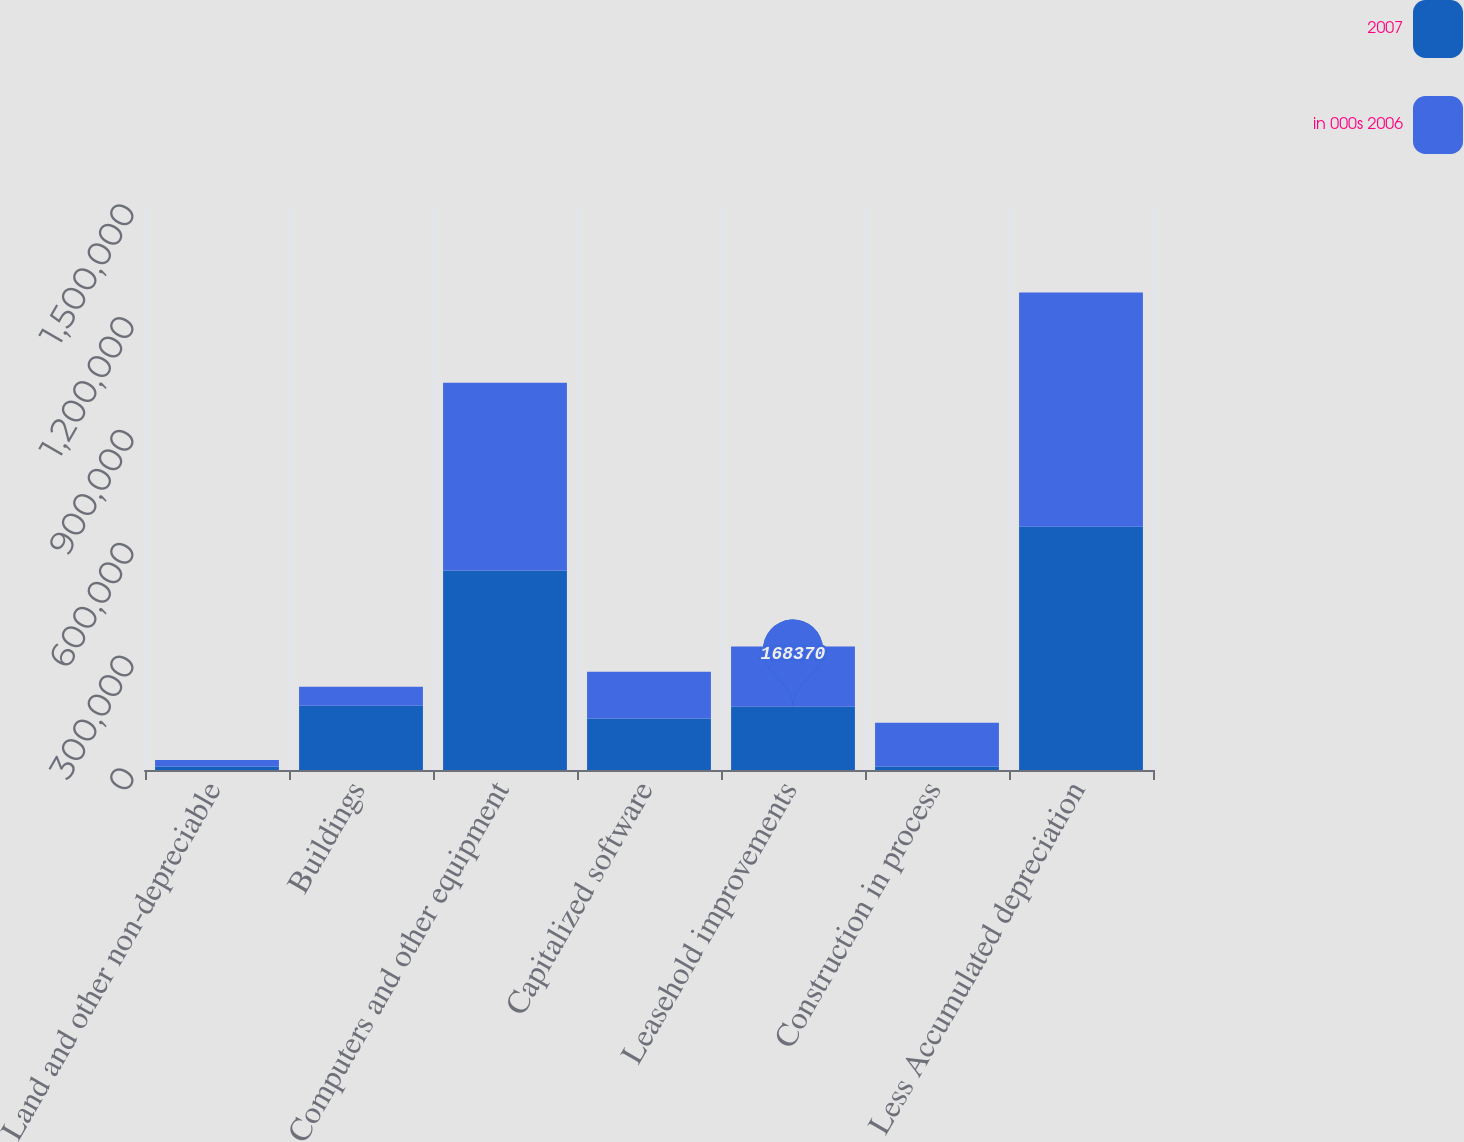Convert chart. <chart><loc_0><loc_0><loc_500><loc_500><stacked_bar_chart><ecel><fcel>Land and other non-depreciable<fcel>Buildings<fcel>Computers and other equipment<fcel>Capitalized software<fcel>Leasehold improvements<fcel>Construction in process<fcel>Less Accumulated depreciation<nl><fcel>2007<fcel>9592<fcel>170904<fcel>530713<fcel>137011<fcel>168370<fcel>9627<fcel>647151<nl><fcel>in 000s 2006<fcel>17152<fcel>50232<fcel>499004<fcel>124065<fcel>159872<fcel>116074<fcel>622693<nl></chart> 